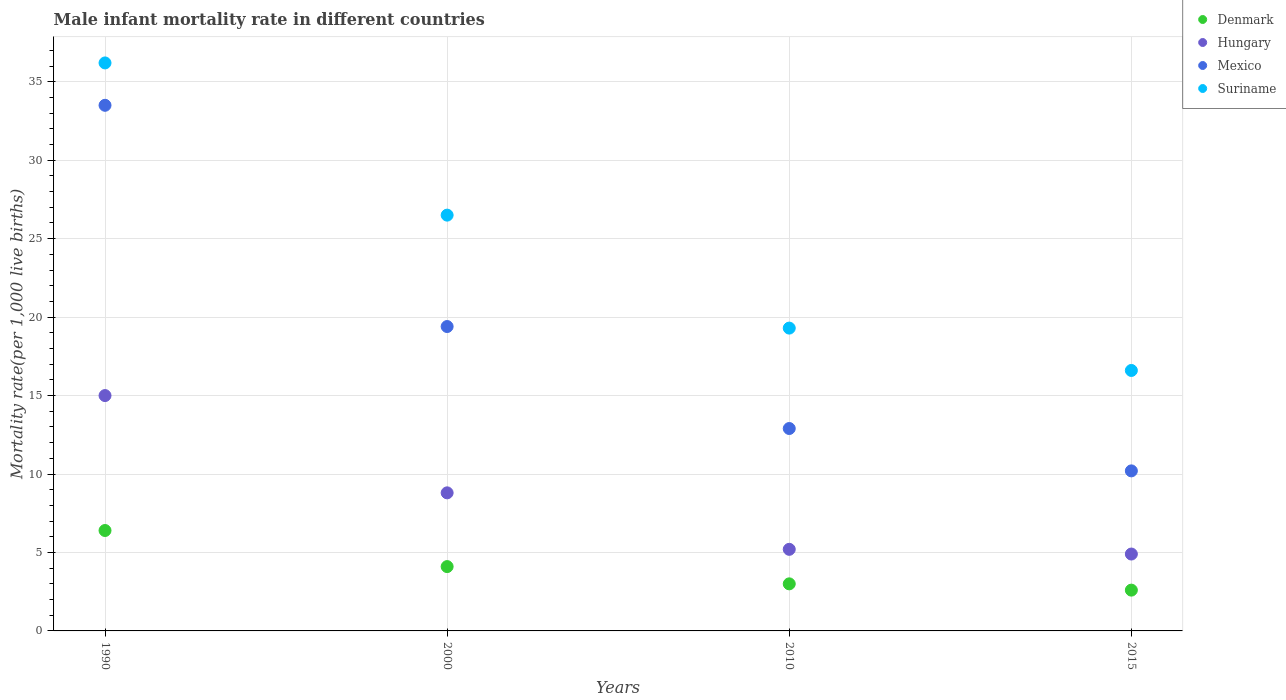How many different coloured dotlines are there?
Provide a succinct answer. 4. Is the number of dotlines equal to the number of legend labels?
Provide a short and direct response. Yes. Across all years, what is the minimum male infant mortality rate in Denmark?
Offer a very short reply. 2.6. In which year was the male infant mortality rate in Hungary minimum?
Provide a short and direct response. 2015. What is the total male infant mortality rate in Suriname in the graph?
Your response must be concise. 98.6. What is the difference between the male infant mortality rate in Denmark in 1990 and that in 2015?
Provide a succinct answer. 3.8. What is the difference between the male infant mortality rate in Suriname in 2000 and the male infant mortality rate in Mexico in 2010?
Provide a succinct answer. 13.6. What is the average male infant mortality rate in Hungary per year?
Your answer should be compact. 8.47. In the year 2000, what is the difference between the male infant mortality rate in Suriname and male infant mortality rate in Mexico?
Your answer should be very brief. 7.1. What is the ratio of the male infant mortality rate in Mexico in 1990 to that in 2015?
Your response must be concise. 3.28. What is the difference between the highest and the second highest male infant mortality rate in Denmark?
Offer a very short reply. 2.3. What is the difference between the highest and the lowest male infant mortality rate in Hungary?
Offer a very short reply. 10.1. Is the sum of the male infant mortality rate in Suriname in 2000 and 2010 greater than the maximum male infant mortality rate in Denmark across all years?
Ensure brevity in your answer.  Yes. Is the male infant mortality rate in Mexico strictly greater than the male infant mortality rate in Suriname over the years?
Keep it short and to the point. No. Are the values on the major ticks of Y-axis written in scientific E-notation?
Your answer should be compact. No. Where does the legend appear in the graph?
Ensure brevity in your answer.  Top right. What is the title of the graph?
Your response must be concise. Male infant mortality rate in different countries. Does "Virgin Islands" appear as one of the legend labels in the graph?
Provide a succinct answer. No. What is the label or title of the X-axis?
Offer a very short reply. Years. What is the label or title of the Y-axis?
Your answer should be very brief. Mortality rate(per 1,0 live births). What is the Mortality rate(per 1,000 live births) in Hungary in 1990?
Your response must be concise. 15. What is the Mortality rate(per 1,000 live births) in Mexico in 1990?
Give a very brief answer. 33.5. What is the Mortality rate(per 1,000 live births) of Suriname in 1990?
Your answer should be very brief. 36.2. What is the Mortality rate(per 1,000 live births) of Denmark in 2000?
Provide a short and direct response. 4.1. What is the Mortality rate(per 1,000 live births) of Mexico in 2000?
Keep it short and to the point. 19.4. What is the Mortality rate(per 1,000 live births) of Hungary in 2010?
Ensure brevity in your answer.  5.2. What is the Mortality rate(per 1,000 live births) of Mexico in 2010?
Give a very brief answer. 12.9. What is the Mortality rate(per 1,000 live births) of Suriname in 2010?
Your answer should be very brief. 19.3. What is the Mortality rate(per 1,000 live births) in Mexico in 2015?
Give a very brief answer. 10.2. Across all years, what is the maximum Mortality rate(per 1,000 live births) of Hungary?
Give a very brief answer. 15. Across all years, what is the maximum Mortality rate(per 1,000 live births) in Mexico?
Your response must be concise. 33.5. Across all years, what is the maximum Mortality rate(per 1,000 live births) of Suriname?
Your answer should be very brief. 36.2. Across all years, what is the minimum Mortality rate(per 1,000 live births) in Hungary?
Offer a very short reply. 4.9. Across all years, what is the minimum Mortality rate(per 1,000 live births) in Mexico?
Provide a short and direct response. 10.2. Across all years, what is the minimum Mortality rate(per 1,000 live births) of Suriname?
Provide a short and direct response. 16.6. What is the total Mortality rate(per 1,000 live births) of Denmark in the graph?
Offer a very short reply. 16.1. What is the total Mortality rate(per 1,000 live births) in Hungary in the graph?
Provide a short and direct response. 33.9. What is the total Mortality rate(per 1,000 live births) of Suriname in the graph?
Provide a succinct answer. 98.6. What is the difference between the Mortality rate(per 1,000 live births) of Denmark in 1990 and that in 2000?
Your response must be concise. 2.3. What is the difference between the Mortality rate(per 1,000 live births) of Hungary in 1990 and that in 2000?
Offer a terse response. 6.2. What is the difference between the Mortality rate(per 1,000 live births) in Suriname in 1990 and that in 2000?
Offer a terse response. 9.7. What is the difference between the Mortality rate(per 1,000 live births) in Denmark in 1990 and that in 2010?
Give a very brief answer. 3.4. What is the difference between the Mortality rate(per 1,000 live births) of Mexico in 1990 and that in 2010?
Keep it short and to the point. 20.6. What is the difference between the Mortality rate(per 1,000 live births) of Suriname in 1990 and that in 2010?
Offer a terse response. 16.9. What is the difference between the Mortality rate(per 1,000 live births) in Mexico in 1990 and that in 2015?
Make the answer very short. 23.3. What is the difference between the Mortality rate(per 1,000 live births) of Suriname in 1990 and that in 2015?
Make the answer very short. 19.6. What is the difference between the Mortality rate(per 1,000 live births) in Suriname in 2000 and that in 2010?
Your answer should be compact. 7.2. What is the difference between the Mortality rate(per 1,000 live births) in Denmark in 2000 and that in 2015?
Keep it short and to the point. 1.5. What is the difference between the Mortality rate(per 1,000 live births) of Denmark in 2010 and that in 2015?
Your answer should be compact. 0.4. What is the difference between the Mortality rate(per 1,000 live births) of Hungary in 2010 and that in 2015?
Provide a succinct answer. 0.3. What is the difference between the Mortality rate(per 1,000 live births) of Mexico in 2010 and that in 2015?
Provide a succinct answer. 2.7. What is the difference between the Mortality rate(per 1,000 live births) of Suriname in 2010 and that in 2015?
Offer a very short reply. 2.7. What is the difference between the Mortality rate(per 1,000 live births) in Denmark in 1990 and the Mortality rate(per 1,000 live births) in Hungary in 2000?
Provide a succinct answer. -2.4. What is the difference between the Mortality rate(per 1,000 live births) in Denmark in 1990 and the Mortality rate(per 1,000 live births) in Suriname in 2000?
Ensure brevity in your answer.  -20.1. What is the difference between the Mortality rate(per 1,000 live births) of Hungary in 1990 and the Mortality rate(per 1,000 live births) of Mexico in 2000?
Provide a short and direct response. -4.4. What is the difference between the Mortality rate(per 1,000 live births) in Denmark in 1990 and the Mortality rate(per 1,000 live births) in Mexico in 2010?
Make the answer very short. -6.5. What is the difference between the Mortality rate(per 1,000 live births) in Hungary in 1990 and the Mortality rate(per 1,000 live births) in Suriname in 2010?
Give a very brief answer. -4.3. What is the difference between the Mortality rate(per 1,000 live births) in Denmark in 1990 and the Mortality rate(per 1,000 live births) in Hungary in 2015?
Provide a short and direct response. 1.5. What is the difference between the Mortality rate(per 1,000 live births) of Denmark in 2000 and the Mortality rate(per 1,000 live births) of Hungary in 2010?
Provide a succinct answer. -1.1. What is the difference between the Mortality rate(per 1,000 live births) of Denmark in 2000 and the Mortality rate(per 1,000 live births) of Suriname in 2010?
Offer a terse response. -15.2. What is the difference between the Mortality rate(per 1,000 live births) of Hungary in 2000 and the Mortality rate(per 1,000 live births) of Suriname in 2010?
Offer a terse response. -10.5. What is the difference between the Mortality rate(per 1,000 live births) of Denmark in 2000 and the Mortality rate(per 1,000 live births) of Mexico in 2015?
Give a very brief answer. -6.1. What is the difference between the Mortality rate(per 1,000 live births) of Hungary in 2000 and the Mortality rate(per 1,000 live births) of Mexico in 2015?
Your response must be concise. -1.4. What is the difference between the Mortality rate(per 1,000 live births) of Mexico in 2000 and the Mortality rate(per 1,000 live births) of Suriname in 2015?
Give a very brief answer. 2.8. What is the difference between the Mortality rate(per 1,000 live births) in Denmark in 2010 and the Mortality rate(per 1,000 live births) in Mexico in 2015?
Your answer should be compact. -7.2. What is the difference between the Mortality rate(per 1,000 live births) of Denmark in 2010 and the Mortality rate(per 1,000 live births) of Suriname in 2015?
Give a very brief answer. -13.6. What is the difference between the Mortality rate(per 1,000 live births) in Hungary in 2010 and the Mortality rate(per 1,000 live births) in Mexico in 2015?
Your answer should be very brief. -5. What is the difference between the Mortality rate(per 1,000 live births) of Hungary in 2010 and the Mortality rate(per 1,000 live births) of Suriname in 2015?
Provide a succinct answer. -11.4. What is the average Mortality rate(per 1,000 live births) in Denmark per year?
Ensure brevity in your answer.  4.03. What is the average Mortality rate(per 1,000 live births) of Hungary per year?
Your answer should be compact. 8.47. What is the average Mortality rate(per 1,000 live births) of Mexico per year?
Your answer should be compact. 19. What is the average Mortality rate(per 1,000 live births) in Suriname per year?
Your response must be concise. 24.65. In the year 1990, what is the difference between the Mortality rate(per 1,000 live births) of Denmark and Mortality rate(per 1,000 live births) of Mexico?
Give a very brief answer. -27.1. In the year 1990, what is the difference between the Mortality rate(per 1,000 live births) in Denmark and Mortality rate(per 1,000 live births) in Suriname?
Keep it short and to the point. -29.8. In the year 1990, what is the difference between the Mortality rate(per 1,000 live births) of Hungary and Mortality rate(per 1,000 live births) of Mexico?
Ensure brevity in your answer.  -18.5. In the year 1990, what is the difference between the Mortality rate(per 1,000 live births) in Hungary and Mortality rate(per 1,000 live births) in Suriname?
Make the answer very short. -21.2. In the year 2000, what is the difference between the Mortality rate(per 1,000 live births) of Denmark and Mortality rate(per 1,000 live births) of Mexico?
Offer a terse response. -15.3. In the year 2000, what is the difference between the Mortality rate(per 1,000 live births) of Denmark and Mortality rate(per 1,000 live births) of Suriname?
Provide a succinct answer. -22.4. In the year 2000, what is the difference between the Mortality rate(per 1,000 live births) in Hungary and Mortality rate(per 1,000 live births) in Mexico?
Ensure brevity in your answer.  -10.6. In the year 2000, what is the difference between the Mortality rate(per 1,000 live births) in Hungary and Mortality rate(per 1,000 live births) in Suriname?
Give a very brief answer. -17.7. In the year 2000, what is the difference between the Mortality rate(per 1,000 live births) of Mexico and Mortality rate(per 1,000 live births) of Suriname?
Your answer should be compact. -7.1. In the year 2010, what is the difference between the Mortality rate(per 1,000 live births) of Denmark and Mortality rate(per 1,000 live births) of Hungary?
Ensure brevity in your answer.  -2.2. In the year 2010, what is the difference between the Mortality rate(per 1,000 live births) in Denmark and Mortality rate(per 1,000 live births) in Mexico?
Provide a short and direct response. -9.9. In the year 2010, what is the difference between the Mortality rate(per 1,000 live births) in Denmark and Mortality rate(per 1,000 live births) in Suriname?
Your answer should be very brief. -16.3. In the year 2010, what is the difference between the Mortality rate(per 1,000 live births) of Hungary and Mortality rate(per 1,000 live births) of Suriname?
Keep it short and to the point. -14.1. In the year 2010, what is the difference between the Mortality rate(per 1,000 live births) of Mexico and Mortality rate(per 1,000 live births) of Suriname?
Offer a terse response. -6.4. In the year 2015, what is the difference between the Mortality rate(per 1,000 live births) in Denmark and Mortality rate(per 1,000 live births) in Hungary?
Provide a short and direct response. -2.3. In the year 2015, what is the difference between the Mortality rate(per 1,000 live births) in Denmark and Mortality rate(per 1,000 live births) in Mexico?
Offer a very short reply. -7.6. In the year 2015, what is the difference between the Mortality rate(per 1,000 live births) in Denmark and Mortality rate(per 1,000 live births) in Suriname?
Ensure brevity in your answer.  -14. In the year 2015, what is the difference between the Mortality rate(per 1,000 live births) in Mexico and Mortality rate(per 1,000 live births) in Suriname?
Give a very brief answer. -6.4. What is the ratio of the Mortality rate(per 1,000 live births) of Denmark in 1990 to that in 2000?
Ensure brevity in your answer.  1.56. What is the ratio of the Mortality rate(per 1,000 live births) in Hungary in 1990 to that in 2000?
Keep it short and to the point. 1.7. What is the ratio of the Mortality rate(per 1,000 live births) in Mexico in 1990 to that in 2000?
Your answer should be compact. 1.73. What is the ratio of the Mortality rate(per 1,000 live births) in Suriname in 1990 to that in 2000?
Your answer should be compact. 1.37. What is the ratio of the Mortality rate(per 1,000 live births) of Denmark in 1990 to that in 2010?
Your answer should be compact. 2.13. What is the ratio of the Mortality rate(per 1,000 live births) of Hungary in 1990 to that in 2010?
Your answer should be very brief. 2.88. What is the ratio of the Mortality rate(per 1,000 live births) of Mexico in 1990 to that in 2010?
Offer a very short reply. 2.6. What is the ratio of the Mortality rate(per 1,000 live births) of Suriname in 1990 to that in 2010?
Keep it short and to the point. 1.88. What is the ratio of the Mortality rate(per 1,000 live births) of Denmark in 1990 to that in 2015?
Provide a succinct answer. 2.46. What is the ratio of the Mortality rate(per 1,000 live births) of Hungary in 1990 to that in 2015?
Ensure brevity in your answer.  3.06. What is the ratio of the Mortality rate(per 1,000 live births) of Mexico in 1990 to that in 2015?
Your answer should be compact. 3.28. What is the ratio of the Mortality rate(per 1,000 live births) of Suriname in 1990 to that in 2015?
Offer a very short reply. 2.18. What is the ratio of the Mortality rate(per 1,000 live births) in Denmark in 2000 to that in 2010?
Give a very brief answer. 1.37. What is the ratio of the Mortality rate(per 1,000 live births) in Hungary in 2000 to that in 2010?
Make the answer very short. 1.69. What is the ratio of the Mortality rate(per 1,000 live births) of Mexico in 2000 to that in 2010?
Offer a terse response. 1.5. What is the ratio of the Mortality rate(per 1,000 live births) of Suriname in 2000 to that in 2010?
Provide a succinct answer. 1.37. What is the ratio of the Mortality rate(per 1,000 live births) of Denmark in 2000 to that in 2015?
Your response must be concise. 1.58. What is the ratio of the Mortality rate(per 1,000 live births) in Hungary in 2000 to that in 2015?
Your answer should be compact. 1.8. What is the ratio of the Mortality rate(per 1,000 live births) in Mexico in 2000 to that in 2015?
Offer a terse response. 1.9. What is the ratio of the Mortality rate(per 1,000 live births) of Suriname in 2000 to that in 2015?
Your answer should be very brief. 1.6. What is the ratio of the Mortality rate(per 1,000 live births) in Denmark in 2010 to that in 2015?
Your answer should be very brief. 1.15. What is the ratio of the Mortality rate(per 1,000 live births) of Hungary in 2010 to that in 2015?
Your answer should be compact. 1.06. What is the ratio of the Mortality rate(per 1,000 live births) in Mexico in 2010 to that in 2015?
Offer a terse response. 1.26. What is the ratio of the Mortality rate(per 1,000 live births) in Suriname in 2010 to that in 2015?
Your answer should be very brief. 1.16. What is the difference between the highest and the second highest Mortality rate(per 1,000 live births) of Denmark?
Provide a short and direct response. 2.3. What is the difference between the highest and the second highest Mortality rate(per 1,000 live births) of Mexico?
Your response must be concise. 14.1. What is the difference between the highest and the lowest Mortality rate(per 1,000 live births) in Mexico?
Make the answer very short. 23.3. What is the difference between the highest and the lowest Mortality rate(per 1,000 live births) in Suriname?
Your answer should be compact. 19.6. 